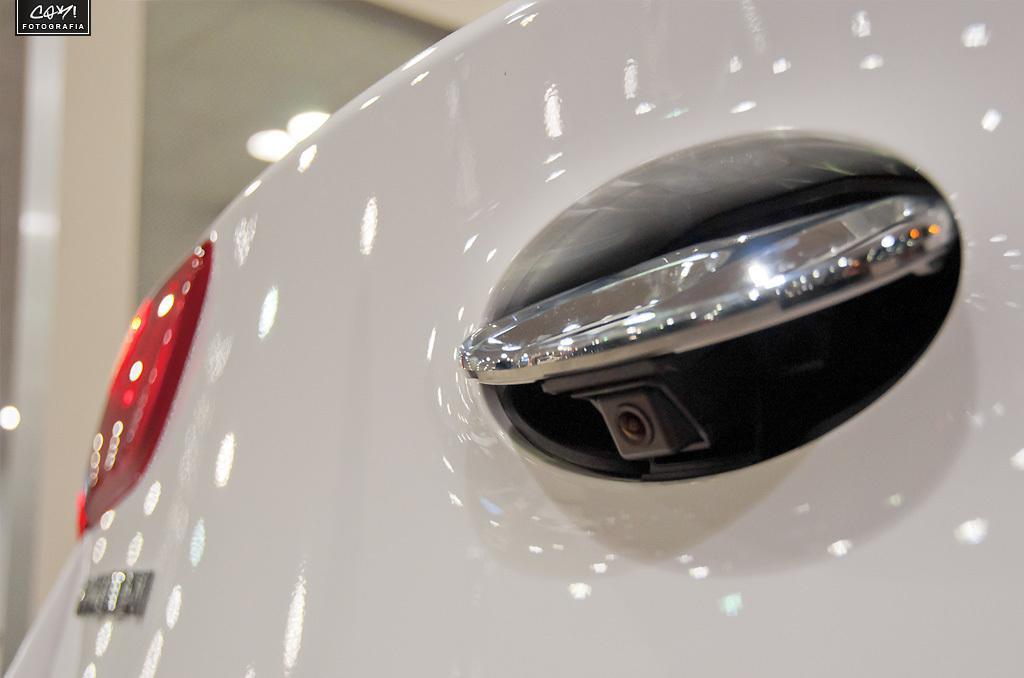In one or two sentences, can you explain what this image depicts? This is a back side of a car with reverse camera and a tail lamp. In the top left corner there is a watermark. 